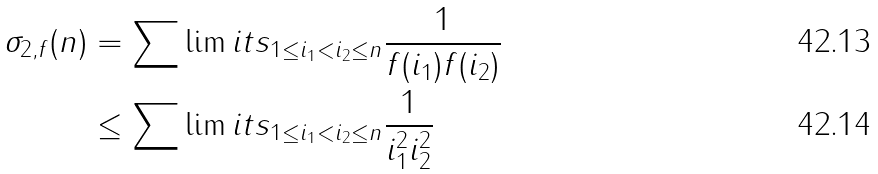<formula> <loc_0><loc_0><loc_500><loc_500>\sigma _ { 2 , f } ( n ) & = \sum \lim i t s _ { 1 \leq i _ { 1 } < i _ { 2 } \leq n } \frac { 1 } { f ( i _ { 1 } ) f ( i _ { 2 } ) } \\ & \leq \sum \lim i t s _ { 1 \leq i _ { 1 } < i _ { 2 } \leq n } \frac { 1 } { i _ { 1 } ^ { 2 } i _ { 2 } ^ { 2 } }</formula> 